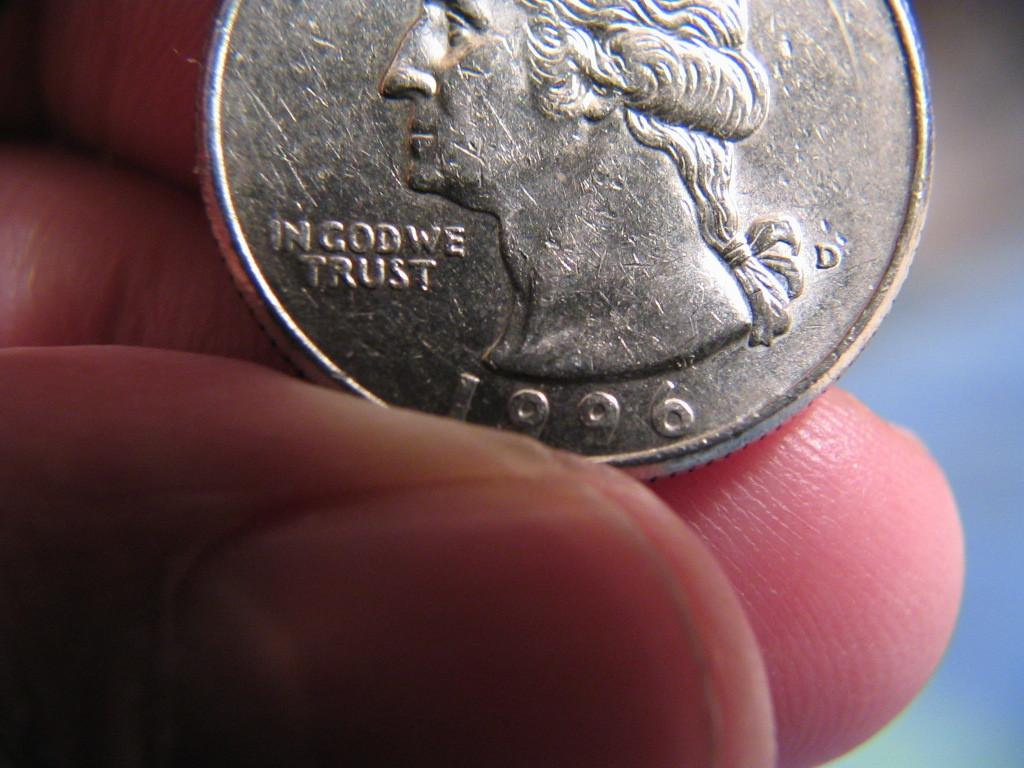<image>
Offer a succinct explanation of the picture presented. the year 1996 is on a quarter someone has 